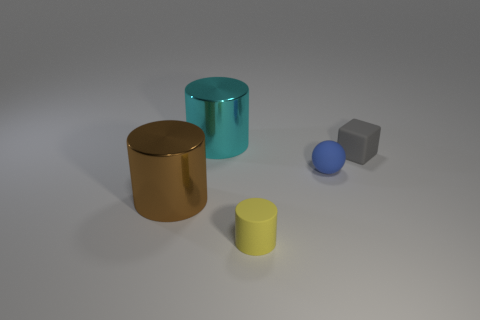Are the tiny object that is in front of the blue sphere and the tiny blue sphere made of the same material?
Provide a short and direct response. Yes. Are there an equal number of matte balls that are in front of the yellow matte object and metal cylinders that are in front of the large cyan cylinder?
Provide a short and direct response. No. There is a cylinder that is behind the rubber block that is to the right of the ball; how big is it?
Your answer should be very brief. Large. The cylinder that is to the right of the brown cylinder and in front of the gray block is made of what material?
Give a very brief answer. Rubber. What number of other objects are the same size as the brown metal thing?
Provide a short and direct response. 1. The sphere is what color?
Your answer should be very brief. Blue. Do the cylinder that is behind the large brown cylinder and the large object in front of the gray matte thing have the same color?
Offer a terse response. No. What size is the cyan metal cylinder?
Give a very brief answer. Large. What is the size of the shiny cylinder in front of the cyan thing?
Ensure brevity in your answer.  Large. There is a thing that is both to the left of the tiny blue rubber thing and right of the big cyan metal cylinder; what shape is it?
Your response must be concise. Cylinder. 